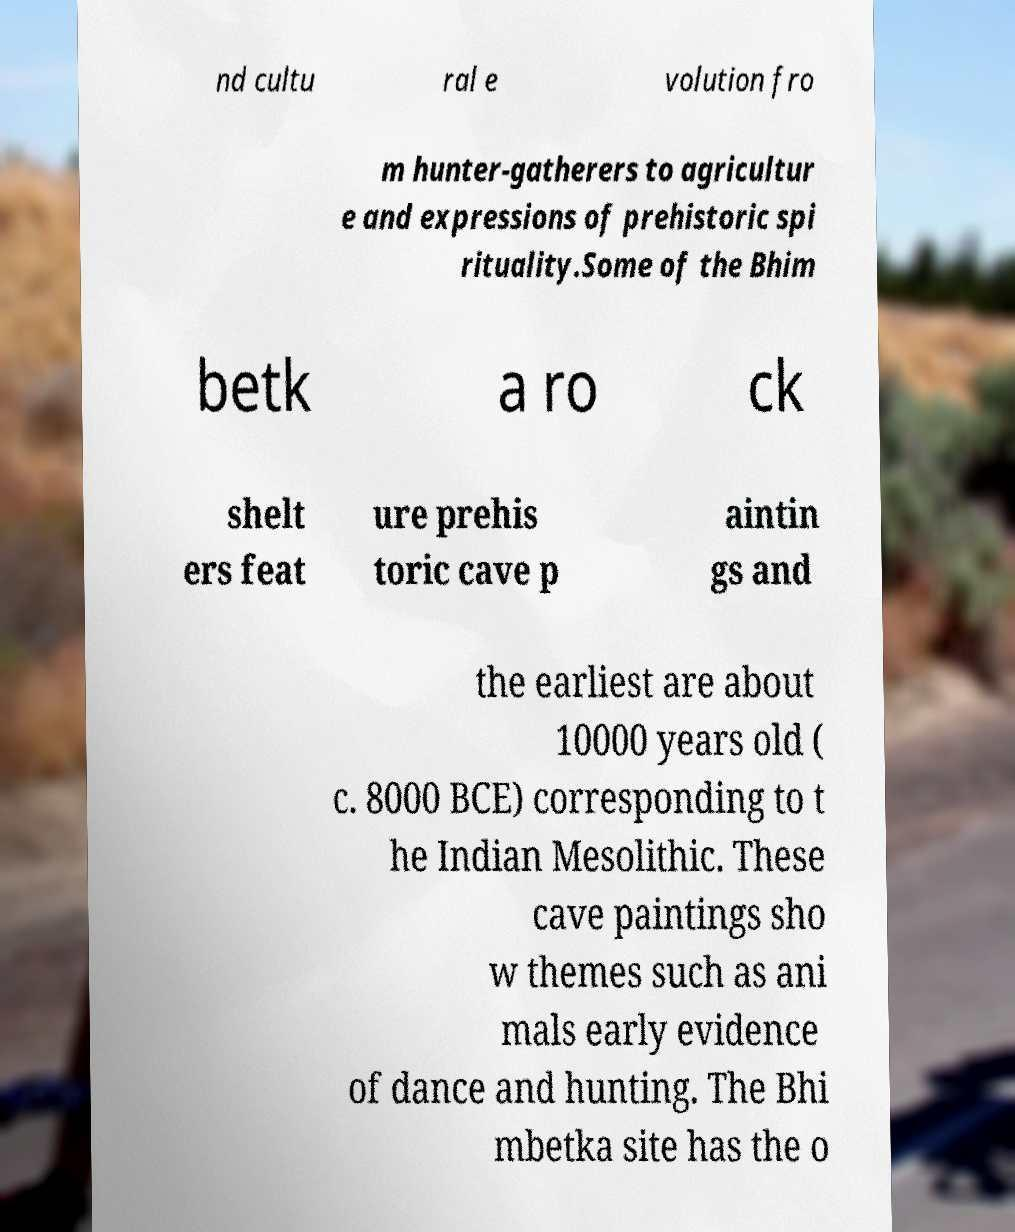For documentation purposes, I need the text within this image transcribed. Could you provide that? nd cultu ral e volution fro m hunter-gatherers to agricultur e and expressions of prehistoric spi rituality.Some of the Bhim betk a ro ck shelt ers feat ure prehis toric cave p aintin gs and the earliest are about 10000 years old ( c. 8000 BCE) corresponding to t he Indian Mesolithic. These cave paintings sho w themes such as ani mals early evidence of dance and hunting. The Bhi mbetka site has the o 